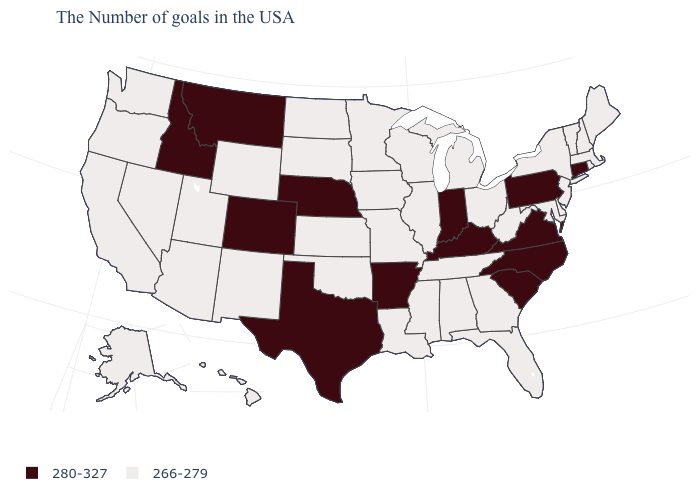What is the value of Florida?
Be succinct. 266-279. How many symbols are there in the legend?
Quick response, please. 2. What is the value of Idaho?
Keep it brief. 280-327. What is the value of Alabama?
Quick response, please. 266-279. What is the value of Vermont?
Be succinct. 266-279. Which states have the lowest value in the West?
Answer briefly. Wyoming, New Mexico, Utah, Arizona, Nevada, California, Washington, Oregon, Alaska, Hawaii. What is the value of Louisiana?
Be succinct. 266-279. Which states hav the highest value in the Northeast?
Short answer required. Connecticut, Pennsylvania. What is the lowest value in the Northeast?
Answer briefly. 266-279. What is the value of Massachusetts?
Keep it brief. 266-279. Name the states that have a value in the range 280-327?
Give a very brief answer. Connecticut, Pennsylvania, Virginia, North Carolina, South Carolina, Kentucky, Indiana, Arkansas, Nebraska, Texas, Colorado, Montana, Idaho. What is the lowest value in the USA?
Answer briefly. 266-279. Name the states that have a value in the range 280-327?
Give a very brief answer. Connecticut, Pennsylvania, Virginia, North Carolina, South Carolina, Kentucky, Indiana, Arkansas, Nebraska, Texas, Colorado, Montana, Idaho. 